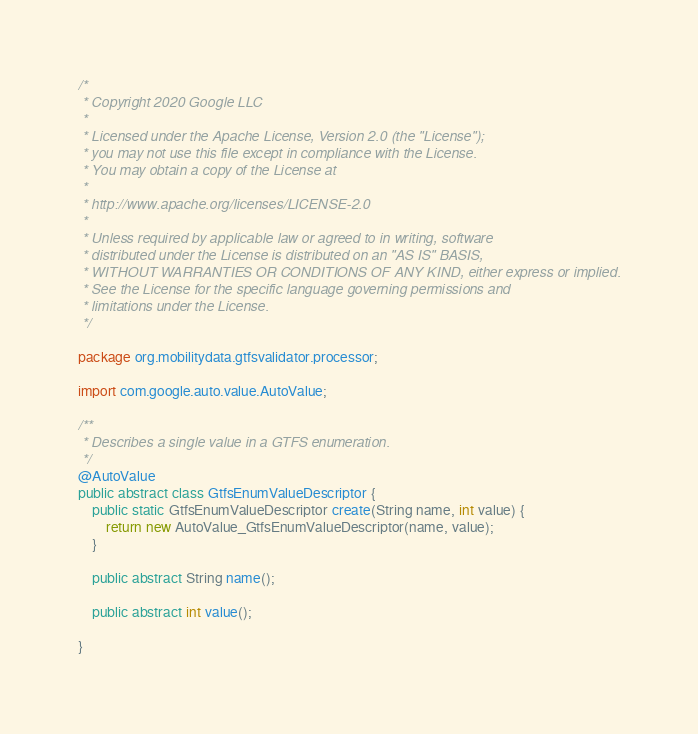Convert code to text. <code><loc_0><loc_0><loc_500><loc_500><_Java_>/*
 * Copyright 2020 Google LLC
 *
 * Licensed under the Apache License, Version 2.0 (the "License");
 * you may not use this file except in compliance with the License.
 * You may obtain a copy of the License at
 *
 * http://www.apache.org/licenses/LICENSE-2.0
 *
 * Unless required by applicable law or agreed to in writing, software
 * distributed under the License is distributed on an "AS IS" BASIS,
 * WITHOUT WARRANTIES OR CONDITIONS OF ANY KIND, either express or implied.
 * See the License for the specific language governing permissions and
 * limitations under the License.
 */

package org.mobilitydata.gtfsvalidator.processor;

import com.google.auto.value.AutoValue;

/**
 * Describes a single value in a GTFS enumeration.
 */
@AutoValue
public abstract class GtfsEnumValueDescriptor {
    public static GtfsEnumValueDescriptor create(String name, int value) {
        return new AutoValue_GtfsEnumValueDescriptor(name, value);
    }

    public abstract String name();

    public abstract int value();

}
</code> 